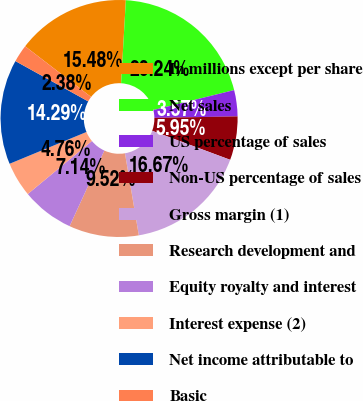<chart> <loc_0><loc_0><loc_500><loc_500><pie_chart><fcel>In millions except per share<fcel>Net sales<fcel>US percentage of sales<fcel>Non-US percentage of sales<fcel>Gross margin (1)<fcel>Research development and<fcel>Equity royalty and interest<fcel>Interest expense (2)<fcel>Net income attributable to<fcel>Basic<nl><fcel>15.48%<fcel>20.24%<fcel>3.57%<fcel>5.95%<fcel>16.67%<fcel>9.52%<fcel>7.14%<fcel>4.76%<fcel>14.29%<fcel>2.38%<nl></chart> 